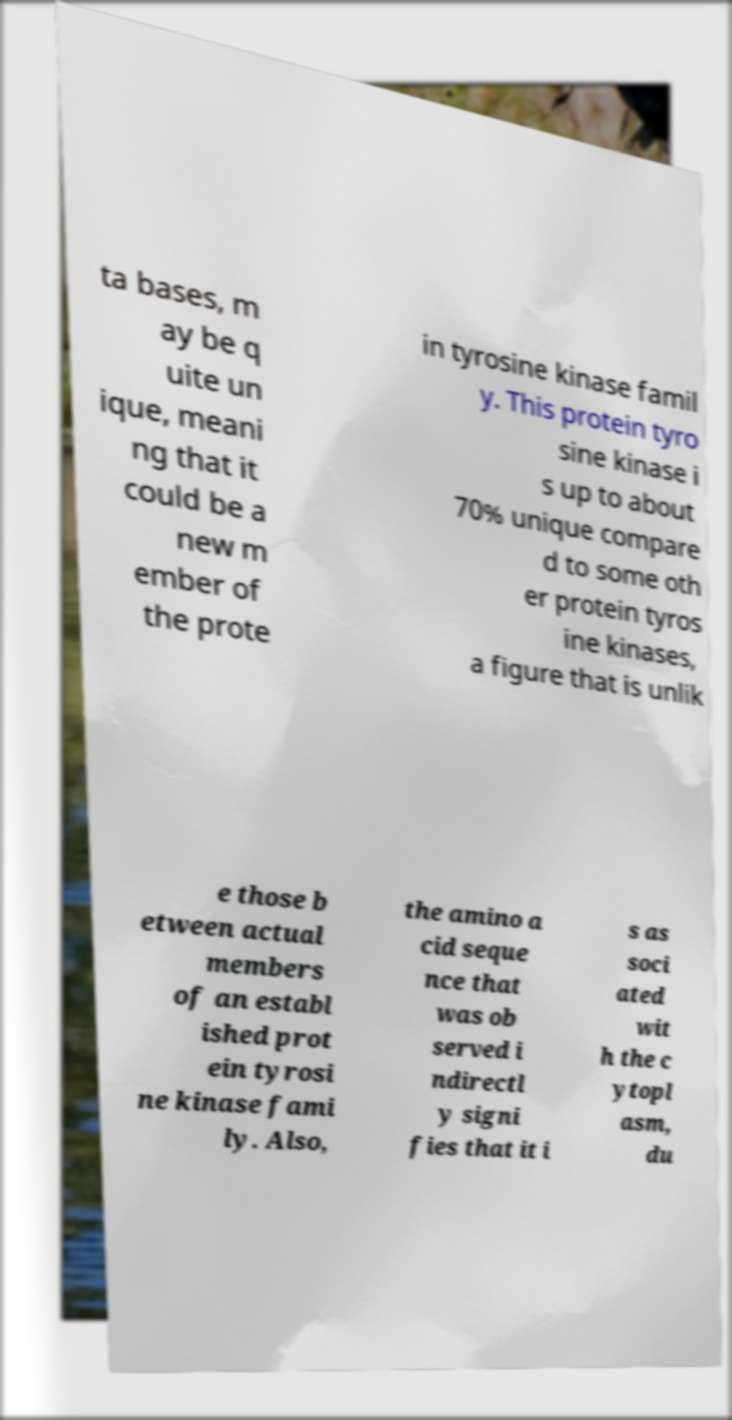There's text embedded in this image that I need extracted. Can you transcribe it verbatim? ta bases, m ay be q uite un ique, meani ng that it could be a new m ember of the prote in tyrosine kinase famil y. This protein tyro sine kinase i s up to about 70% unique compare d to some oth er protein tyros ine kinases, a figure that is unlik e those b etween actual members of an establ ished prot ein tyrosi ne kinase fami ly. Also, the amino a cid seque nce that was ob served i ndirectl y signi fies that it i s as soci ated wit h the c ytopl asm, du 